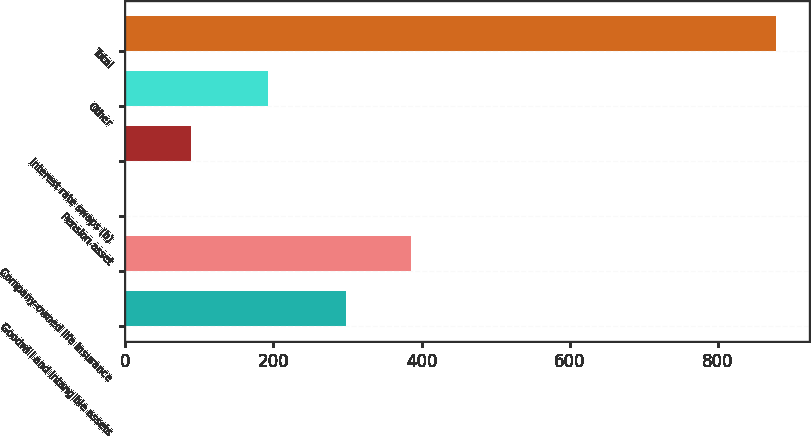Convert chart. <chart><loc_0><loc_0><loc_500><loc_500><bar_chart><fcel>Goodwill and intangible assets<fcel>Company-owned life insurance<fcel>Pension asset<fcel>Interest rate swaps (b)<fcel>Other<fcel>Total<nl><fcel>298<fcel>385.8<fcel>1<fcel>88.8<fcel>193<fcel>879<nl></chart> 